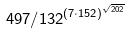<formula> <loc_0><loc_0><loc_500><loc_500>4 9 7 / 1 3 2 ^ { ( 7 \cdot 1 5 2 ) ^ { \sqrt { 2 0 2 } } }</formula> 